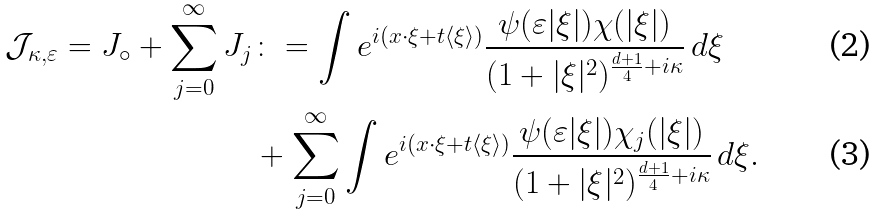<formula> <loc_0><loc_0><loc_500><loc_500>\mathcal { J } _ { \kappa , \varepsilon } = J _ { \circ } + \sum _ { j = 0 } ^ { \infty } J _ { j } & \colon = \int e ^ { i ( x \cdot \xi + t \langle \xi \rangle ) } \frac { \psi ( \varepsilon | \xi | ) \chi ( | \xi | ) } { ( 1 + | \xi | ^ { 2 } ) ^ { \frac { d + 1 } 4 + i \kappa } } \, d \xi \\ \quad & + \sum _ { j = 0 } ^ { \infty } \int e ^ { i ( x \cdot \xi + t \langle \xi \rangle ) } \frac { \psi ( \varepsilon | \xi | ) \chi _ { j } ( | \xi | ) } { ( 1 + | \xi | ^ { 2 } ) ^ { \frac { d + 1 } 4 + i \kappa } } \, d \xi .</formula> 